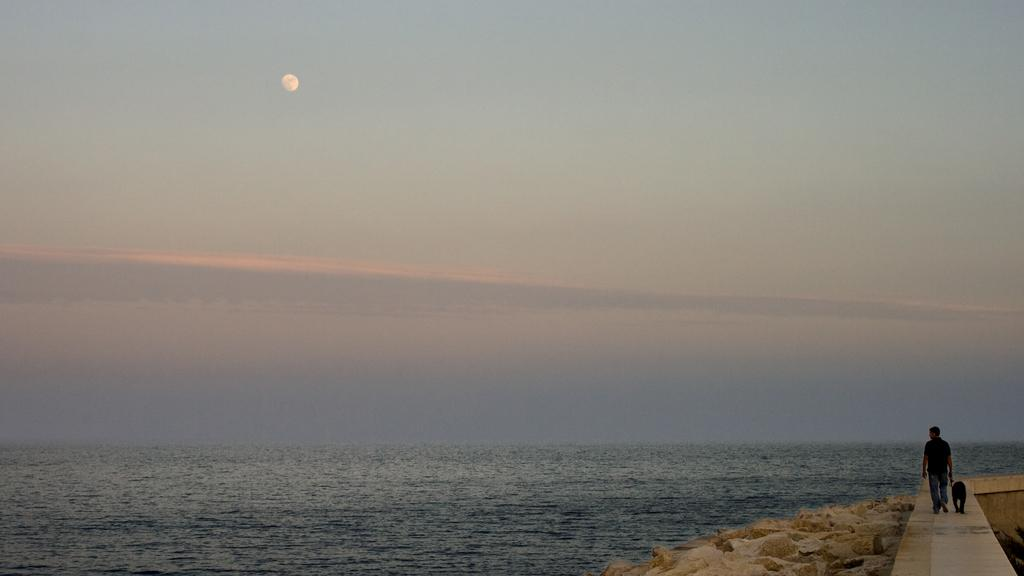What is the main setting of the image? There is a sea in the image. What is the person in the image doing? The person is walking along a path in the image. Is the person accompanied by any other living creature? Yes, the person has a dog beside them. What type of whip is the person using to control the dog in the image? There is no whip present in the image, and the person is not controlling the dog with any such object. 